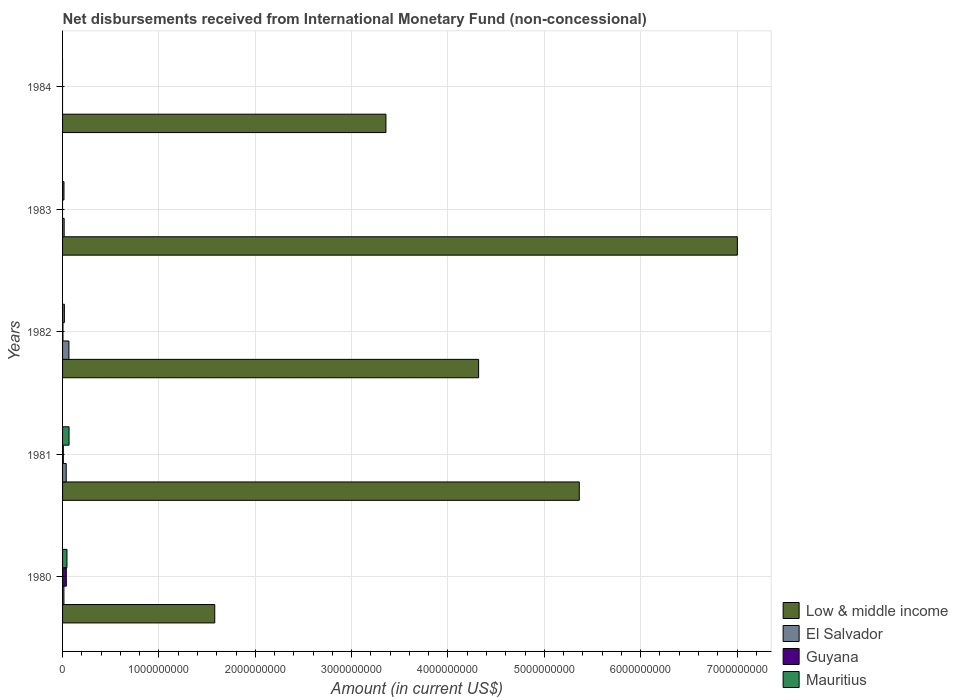Are the number of bars per tick equal to the number of legend labels?
Offer a terse response. No. How many bars are there on the 3rd tick from the top?
Make the answer very short. 4. How many bars are there on the 2nd tick from the bottom?
Ensure brevity in your answer.  4. Across all years, what is the maximum amount of disbursements received from International Monetary Fund in Guyana?
Your response must be concise. 3.90e+07. Across all years, what is the minimum amount of disbursements received from International Monetary Fund in El Salvador?
Provide a short and direct response. 0. In which year was the amount of disbursements received from International Monetary Fund in El Salvador maximum?
Your response must be concise. 1982. What is the total amount of disbursements received from International Monetary Fund in Guyana in the graph?
Provide a short and direct response. 5.10e+07. What is the difference between the amount of disbursements received from International Monetary Fund in El Salvador in 1982 and that in 1983?
Your answer should be compact. 4.94e+07. What is the difference between the amount of disbursements received from International Monetary Fund in Mauritius in 1983 and the amount of disbursements received from International Monetary Fund in El Salvador in 1984?
Keep it short and to the point. 1.48e+07. What is the average amount of disbursements received from International Monetary Fund in El Salvador per year?
Provide a short and direct response. 2.69e+07. In the year 1980, what is the difference between the amount of disbursements received from International Monetary Fund in El Salvador and amount of disbursements received from International Monetary Fund in Low & middle income?
Provide a short and direct response. -1.57e+09. In how many years, is the amount of disbursements received from International Monetary Fund in Guyana greater than 6000000000 US$?
Give a very brief answer. 0. What is the ratio of the amount of disbursements received from International Monetary Fund in El Salvador in 1980 to that in 1983?
Offer a very short reply. 0.85. What is the difference between the highest and the second highest amount of disbursements received from International Monetary Fund in Low & middle income?
Ensure brevity in your answer.  1.64e+09. What is the difference between the highest and the lowest amount of disbursements received from International Monetary Fund in El Salvador?
Offer a very short reply. 6.60e+07. How many bars are there?
Keep it short and to the point. 16. Are all the bars in the graph horizontal?
Provide a succinct answer. Yes. How many years are there in the graph?
Offer a very short reply. 5. What is the difference between two consecutive major ticks on the X-axis?
Give a very brief answer. 1.00e+09. Are the values on the major ticks of X-axis written in scientific E-notation?
Give a very brief answer. No. Does the graph contain grids?
Provide a succinct answer. Yes. Where does the legend appear in the graph?
Give a very brief answer. Bottom right. How many legend labels are there?
Provide a short and direct response. 4. What is the title of the graph?
Offer a very short reply. Net disbursements received from International Monetary Fund (non-concessional). What is the label or title of the X-axis?
Ensure brevity in your answer.  Amount (in current US$). What is the label or title of the Y-axis?
Offer a very short reply. Years. What is the Amount (in current US$) of Low & middle income in 1980?
Ensure brevity in your answer.  1.58e+09. What is the Amount (in current US$) in El Salvador in 1980?
Provide a short and direct response. 1.41e+07. What is the Amount (in current US$) of Guyana in 1980?
Provide a short and direct response. 3.90e+07. What is the Amount (in current US$) of Mauritius in 1980?
Give a very brief answer. 4.56e+07. What is the Amount (in current US$) in Low & middle income in 1981?
Offer a terse response. 5.36e+09. What is the Amount (in current US$) in El Salvador in 1981?
Offer a terse response. 3.80e+07. What is the Amount (in current US$) of Guyana in 1981?
Provide a short and direct response. 7.90e+06. What is the Amount (in current US$) in Mauritius in 1981?
Provide a succinct answer. 6.72e+07. What is the Amount (in current US$) of Low & middle income in 1982?
Give a very brief answer. 4.32e+09. What is the Amount (in current US$) of El Salvador in 1982?
Keep it short and to the point. 6.60e+07. What is the Amount (in current US$) in Guyana in 1982?
Provide a succinct answer. 4.10e+06. What is the Amount (in current US$) in Mauritius in 1982?
Provide a short and direct response. 1.87e+07. What is the Amount (in current US$) in Low & middle income in 1983?
Offer a terse response. 7.00e+09. What is the Amount (in current US$) of El Salvador in 1983?
Provide a succinct answer. 1.66e+07. What is the Amount (in current US$) of Guyana in 1983?
Keep it short and to the point. 0. What is the Amount (in current US$) in Mauritius in 1983?
Your answer should be very brief. 1.48e+07. What is the Amount (in current US$) of Low & middle income in 1984?
Ensure brevity in your answer.  3.36e+09. What is the Amount (in current US$) in El Salvador in 1984?
Keep it short and to the point. 0. What is the Amount (in current US$) of Mauritius in 1984?
Give a very brief answer. 0. Across all years, what is the maximum Amount (in current US$) in Low & middle income?
Provide a succinct answer. 7.00e+09. Across all years, what is the maximum Amount (in current US$) in El Salvador?
Offer a terse response. 6.60e+07. Across all years, what is the maximum Amount (in current US$) of Guyana?
Offer a terse response. 3.90e+07. Across all years, what is the maximum Amount (in current US$) of Mauritius?
Make the answer very short. 6.72e+07. Across all years, what is the minimum Amount (in current US$) of Low & middle income?
Provide a short and direct response. 1.58e+09. Across all years, what is the minimum Amount (in current US$) of El Salvador?
Offer a terse response. 0. Across all years, what is the minimum Amount (in current US$) of Guyana?
Give a very brief answer. 0. Across all years, what is the minimum Amount (in current US$) in Mauritius?
Ensure brevity in your answer.  0. What is the total Amount (in current US$) of Low & middle income in the graph?
Give a very brief answer. 2.16e+1. What is the total Amount (in current US$) in El Salvador in the graph?
Offer a very short reply. 1.35e+08. What is the total Amount (in current US$) in Guyana in the graph?
Provide a short and direct response. 5.10e+07. What is the total Amount (in current US$) in Mauritius in the graph?
Make the answer very short. 1.46e+08. What is the difference between the Amount (in current US$) in Low & middle income in 1980 and that in 1981?
Offer a terse response. -3.78e+09. What is the difference between the Amount (in current US$) in El Salvador in 1980 and that in 1981?
Give a very brief answer. -2.39e+07. What is the difference between the Amount (in current US$) in Guyana in 1980 and that in 1981?
Offer a very short reply. 3.11e+07. What is the difference between the Amount (in current US$) of Mauritius in 1980 and that in 1981?
Your response must be concise. -2.16e+07. What is the difference between the Amount (in current US$) in Low & middle income in 1980 and that in 1982?
Your answer should be very brief. -2.74e+09. What is the difference between the Amount (in current US$) of El Salvador in 1980 and that in 1982?
Offer a very short reply. -5.19e+07. What is the difference between the Amount (in current US$) in Guyana in 1980 and that in 1982?
Offer a very short reply. 3.49e+07. What is the difference between the Amount (in current US$) of Mauritius in 1980 and that in 1982?
Your response must be concise. 2.69e+07. What is the difference between the Amount (in current US$) in Low & middle income in 1980 and that in 1983?
Offer a terse response. -5.42e+09. What is the difference between the Amount (in current US$) of El Salvador in 1980 and that in 1983?
Keep it short and to the point. -2.47e+06. What is the difference between the Amount (in current US$) in Mauritius in 1980 and that in 1983?
Your answer should be compact. 3.08e+07. What is the difference between the Amount (in current US$) in Low & middle income in 1980 and that in 1984?
Offer a very short reply. -1.78e+09. What is the difference between the Amount (in current US$) in Low & middle income in 1981 and that in 1982?
Your answer should be very brief. 1.04e+09. What is the difference between the Amount (in current US$) of El Salvador in 1981 and that in 1982?
Make the answer very short. -2.80e+07. What is the difference between the Amount (in current US$) in Guyana in 1981 and that in 1982?
Offer a very short reply. 3.80e+06. What is the difference between the Amount (in current US$) of Mauritius in 1981 and that in 1982?
Keep it short and to the point. 4.85e+07. What is the difference between the Amount (in current US$) in Low & middle income in 1981 and that in 1983?
Provide a short and direct response. -1.64e+09. What is the difference between the Amount (in current US$) in El Salvador in 1981 and that in 1983?
Your response must be concise. 2.14e+07. What is the difference between the Amount (in current US$) in Mauritius in 1981 and that in 1983?
Provide a succinct answer. 5.24e+07. What is the difference between the Amount (in current US$) in Low & middle income in 1981 and that in 1984?
Provide a short and direct response. 2.01e+09. What is the difference between the Amount (in current US$) in Low & middle income in 1982 and that in 1983?
Your answer should be compact. -2.69e+09. What is the difference between the Amount (in current US$) in El Salvador in 1982 and that in 1983?
Keep it short and to the point. 4.94e+07. What is the difference between the Amount (in current US$) in Mauritius in 1982 and that in 1983?
Your answer should be very brief. 3.94e+06. What is the difference between the Amount (in current US$) of Low & middle income in 1982 and that in 1984?
Offer a terse response. 9.62e+08. What is the difference between the Amount (in current US$) of Low & middle income in 1983 and that in 1984?
Offer a very short reply. 3.65e+09. What is the difference between the Amount (in current US$) of Low & middle income in 1980 and the Amount (in current US$) of El Salvador in 1981?
Your answer should be compact. 1.54e+09. What is the difference between the Amount (in current US$) of Low & middle income in 1980 and the Amount (in current US$) of Guyana in 1981?
Offer a very short reply. 1.57e+09. What is the difference between the Amount (in current US$) in Low & middle income in 1980 and the Amount (in current US$) in Mauritius in 1981?
Your response must be concise. 1.51e+09. What is the difference between the Amount (in current US$) of El Salvador in 1980 and the Amount (in current US$) of Guyana in 1981?
Offer a very short reply. 6.20e+06. What is the difference between the Amount (in current US$) in El Salvador in 1980 and the Amount (in current US$) in Mauritius in 1981?
Make the answer very short. -5.31e+07. What is the difference between the Amount (in current US$) of Guyana in 1980 and the Amount (in current US$) of Mauritius in 1981?
Offer a very short reply. -2.82e+07. What is the difference between the Amount (in current US$) in Low & middle income in 1980 and the Amount (in current US$) in El Salvador in 1982?
Your answer should be very brief. 1.51e+09. What is the difference between the Amount (in current US$) of Low & middle income in 1980 and the Amount (in current US$) of Guyana in 1982?
Offer a very short reply. 1.58e+09. What is the difference between the Amount (in current US$) of Low & middle income in 1980 and the Amount (in current US$) of Mauritius in 1982?
Provide a short and direct response. 1.56e+09. What is the difference between the Amount (in current US$) of El Salvador in 1980 and the Amount (in current US$) of Guyana in 1982?
Your response must be concise. 1.00e+07. What is the difference between the Amount (in current US$) in El Salvador in 1980 and the Amount (in current US$) in Mauritius in 1982?
Keep it short and to the point. -4.64e+06. What is the difference between the Amount (in current US$) in Guyana in 1980 and the Amount (in current US$) in Mauritius in 1982?
Give a very brief answer. 2.03e+07. What is the difference between the Amount (in current US$) of Low & middle income in 1980 and the Amount (in current US$) of El Salvador in 1983?
Offer a terse response. 1.56e+09. What is the difference between the Amount (in current US$) of Low & middle income in 1980 and the Amount (in current US$) of Mauritius in 1983?
Offer a terse response. 1.56e+09. What is the difference between the Amount (in current US$) in El Salvador in 1980 and the Amount (in current US$) in Mauritius in 1983?
Ensure brevity in your answer.  -7.00e+05. What is the difference between the Amount (in current US$) in Guyana in 1980 and the Amount (in current US$) in Mauritius in 1983?
Ensure brevity in your answer.  2.42e+07. What is the difference between the Amount (in current US$) of Low & middle income in 1981 and the Amount (in current US$) of El Salvador in 1982?
Ensure brevity in your answer.  5.30e+09. What is the difference between the Amount (in current US$) in Low & middle income in 1981 and the Amount (in current US$) in Guyana in 1982?
Your answer should be very brief. 5.36e+09. What is the difference between the Amount (in current US$) in Low & middle income in 1981 and the Amount (in current US$) in Mauritius in 1982?
Provide a succinct answer. 5.34e+09. What is the difference between the Amount (in current US$) of El Salvador in 1981 and the Amount (in current US$) of Guyana in 1982?
Provide a short and direct response. 3.39e+07. What is the difference between the Amount (in current US$) in El Salvador in 1981 and the Amount (in current US$) in Mauritius in 1982?
Keep it short and to the point. 1.93e+07. What is the difference between the Amount (in current US$) of Guyana in 1981 and the Amount (in current US$) of Mauritius in 1982?
Make the answer very short. -1.08e+07. What is the difference between the Amount (in current US$) in Low & middle income in 1981 and the Amount (in current US$) in El Salvador in 1983?
Your response must be concise. 5.35e+09. What is the difference between the Amount (in current US$) of Low & middle income in 1981 and the Amount (in current US$) of Mauritius in 1983?
Give a very brief answer. 5.35e+09. What is the difference between the Amount (in current US$) of El Salvador in 1981 and the Amount (in current US$) of Mauritius in 1983?
Provide a short and direct response. 2.32e+07. What is the difference between the Amount (in current US$) in Guyana in 1981 and the Amount (in current US$) in Mauritius in 1983?
Your answer should be very brief. -6.90e+06. What is the difference between the Amount (in current US$) in Low & middle income in 1982 and the Amount (in current US$) in El Salvador in 1983?
Make the answer very short. 4.30e+09. What is the difference between the Amount (in current US$) of Low & middle income in 1982 and the Amount (in current US$) of Mauritius in 1983?
Your response must be concise. 4.30e+09. What is the difference between the Amount (in current US$) of El Salvador in 1982 and the Amount (in current US$) of Mauritius in 1983?
Your response must be concise. 5.12e+07. What is the difference between the Amount (in current US$) of Guyana in 1982 and the Amount (in current US$) of Mauritius in 1983?
Offer a very short reply. -1.07e+07. What is the average Amount (in current US$) in Low & middle income per year?
Your answer should be very brief. 4.32e+09. What is the average Amount (in current US$) of El Salvador per year?
Your answer should be compact. 2.69e+07. What is the average Amount (in current US$) in Guyana per year?
Offer a very short reply. 1.02e+07. What is the average Amount (in current US$) in Mauritius per year?
Your answer should be compact. 2.93e+07. In the year 1980, what is the difference between the Amount (in current US$) of Low & middle income and Amount (in current US$) of El Salvador?
Offer a terse response. 1.57e+09. In the year 1980, what is the difference between the Amount (in current US$) of Low & middle income and Amount (in current US$) of Guyana?
Keep it short and to the point. 1.54e+09. In the year 1980, what is the difference between the Amount (in current US$) of Low & middle income and Amount (in current US$) of Mauritius?
Ensure brevity in your answer.  1.53e+09. In the year 1980, what is the difference between the Amount (in current US$) in El Salvador and Amount (in current US$) in Guyana?
Your answer should be compact. -2.49e+07. In the year 1980, what is the difference between the Amount (in current US$) of El Salvador and Amount (in current US$) of Mauritius?
Provide a succinct answer. -3.15e+07. In the year 1980, what is the difference between the Amount (in current US$) of Guyana and Amount (in current US$) of Mauritius?
Ensure brevity in your answer.  -6.60e+06. In the year 1981, what is the difference between the Amount (in current US$) of Low & middle income and Amount (in current US$) of El Salvador?
Offer a terse response. 5.32e+09. In the year 1981, what is the difference between the Amount (in current US$) in Low & middle income and Amount (in current US$) in Guyana?
Your answer should be compact. 5.35e+09. In the year 1981, what is the difference between the Amount (in current US$) in Low & middle income and Amount (in current US$) in Mauritius?
Your response must be concise. 5.30e+09. In the year 1981, what is the difference between the Amount (in current US$) of El Salvador and Amount (in current US$) of Guyana?
Ensure brevity in your answer.  3.01e+07. In the year 1981, what is the difference between the Amount (in current US$) in El Salvador and Amount (in current US$) in Mauritius?
Your response must be concise. -2.92e+07. In the year 1981, what is the difference between the Amount (in current US$) in Guyana and Amount (in current US$) in Mauritius?
Keep it short and to the point. -5.93e+07. In the year 1982, what is the difference between the Amount (in current US$) in Low & middle income and Amount (in current US$) in El Salvador?
Offer a very short reply. 4.25e+09. In the year 1982, what is the difference between the Amount (in current US$) of Low & middle income and Amount (in current US$) of Guyana?
Your answer should be very brief. 4.31e+09. In the year 1982, what is the difference between the Amount (in current US$) of Low & middle income and Amount (in current US$) of Mauritius?
Your answer should be compact. 4.30e+09. In the year 1982, what is the difference between the Amount (in current US$) in El Salvador and Amount (in current US$) in Guyana?
Keep it short and to the point. 6.19e+07. In the year 1982, what is the difference between the Amount (in current US$) of El Salvador and Amount (in current US$) of Mauritius?
Offer a terse response. 4.73e+07. In the year 1982, what is the difference between the Amount (in current US$) in Guyana and Amount (in current US$) in Mauritius?
Provide a succinct answer. -1.46e+07. In the year 1983, what is the difference between the Amount (in current US$) of Low & middle income and Amount (in current US$) of El Salvador?
Provide a succinct answer. 6.99e+09. In the year 1983, what is the difference between the Amount (in current US$) in Low & middle income and Amount (in current US$) in Mauritius?
Give a very brief answer. 6.99e+09. In the year 1983, what is the difference between the Amount (in current US$) of El Salvador and Amount (in current US$) of Mauritius?
Your answer should be very brief. 1.77e+06. What is the ratio of the Amount (in current US$) of Low & middle income in 1980 to that in 1981?
Keep it short and to the point. 0.29. What is the ratio of the Amount (in current US$) in El Salvador in 1980 to that in 1981?
Offer a terse response. 0.37. What is the ratio of the Amount (in current US$) in Guyana in 1980 to that in 1981?
Provide a short and direct response. 4.94. What is the ratio of the Amount (in current US$) in Mauritius in 1980 to that in 1981?
Provide a short and direct response. 0.68. What is the ratio of the Amount (in current US$) in Low & middle income in 1980 to that in 1982?
Provide a succinct answer. 0.37. What is the ratio of the Amount (in current US$) of El Salvador in 1980 to that in 1982?
Your answer should be very brief. 0.21. What is the ratio of the Amount (in current US$) of Guyana in 1980 to that in 1982?
Give a very brief answer. 9.51. What is the ratio of the Amount (in current US$) in Mauritius in 1980 to that in 1982?
Provide a succinct answer. 2.43. What is the ratio of the Amount (in current US$) in Low & middle income in 1980 to that in 1983?
Your answer should be compact. 0.23. What is the ratio of the Amount (in current US$) of El Salvador in 1980 to that in 1983?
Your answer should be very brief. 0.85. What is the ratio of the Amount (in current US$) in Mauritius in 1980 to that in 1983?
Your answer should be compact. 3.08. What is the ratio of the Amount (in current US$) of Low & middle income in 1980 to that in 1984?
Offer a very short reply. 0.47. What is the ratio of the Amount (in current US$) in Low & middle income in 1981 to that in 1982?
Offer a very short reply. 1.24. What is the ratio of the Amount (in current US$) in El Salvador in 1981 to that in 1982?
Give a very brief answer. 0.58. What is the ratio of the Amount (in current US$) in Guyana in 1981 to that in 1982?
Provide a short and direct response. 1.93. What is the ratio of the Amount (in current US$) in Mauritius in 1981 to that in 1982?
Your answer should be compact. 3.59. What is the ratio of the Amount (in current US$) of Low & middle income in 1981 to that in 1983?
Offer a very short reply. 0.77. What is the ratio of the Amount (in current US$) in El Salvador in 1981 to that in 1983?
Make the answer very short. 2.29. What is the ratio of the Amount (in current US$) of Mauritius in 1981 to that in 1983?
Your answer should be very brief. 4.54. What is the ratio of the Amount (in current US$) in Low & middle income in 1981 to that in 1984?
Ensure brevity in your answer.  1.6. What is the ratio of the Amount (in current US$) of Low & middle income in 1982 to that in 1983?
Keep it short and to the point. 0.62. What is the ratio of the Amount (in current US$) in El Salvador in 1982 to that in 1983?
Make the answer very short. 3.98. What is the ratio of the Amount (in current US$) in Mauritius in 1982 to that in 1983?
Provide a succinct answer. 1.27. What is the ratio of the Amount (in current US$) of Low & middle income in 1982 to that in 1984?
Your answer should be very brief. 1.29. What is the ratio of the Amount (in current US$) of Low & middle income in 1983 to that in 1984?
Your answer should be compact. 2.09. What is the difference between the highest and the second highest Amount (in current US$) of Low & middle income?
Provide a succinct answer. 1.64e+09. What is the difference between the highest and the second highest Amount (in current US$) of El Salvador?
Your response must be concise. 2.80e+07. What is the difference between the highest and the second highest Amount (in current US$) in Guyana?
Keep it short and to the point. 3.11e+07. What is the difference between the highest and the second highest Amount (in current US$) in Mauritius?
Keep it short and to the point. 2.16e+07. What is the difference between the highest and the lowest Amount (in current US$) of Low & middle income?
Your answer should be compact. 5.42e+09. What is the difference between the highest and the lowest Amount (in current US$) of El Salvador?
Your response must be concise. 6.60e+07. What is the difference between the highest and the lowest Amount (in current US$) of Guyana?
Provide a succinct answer. 3.90e+07. What is the difference between the highest and the lowest Amount (in current US$) in Mauritius?
Offer a terse response. 6.72e+07. 